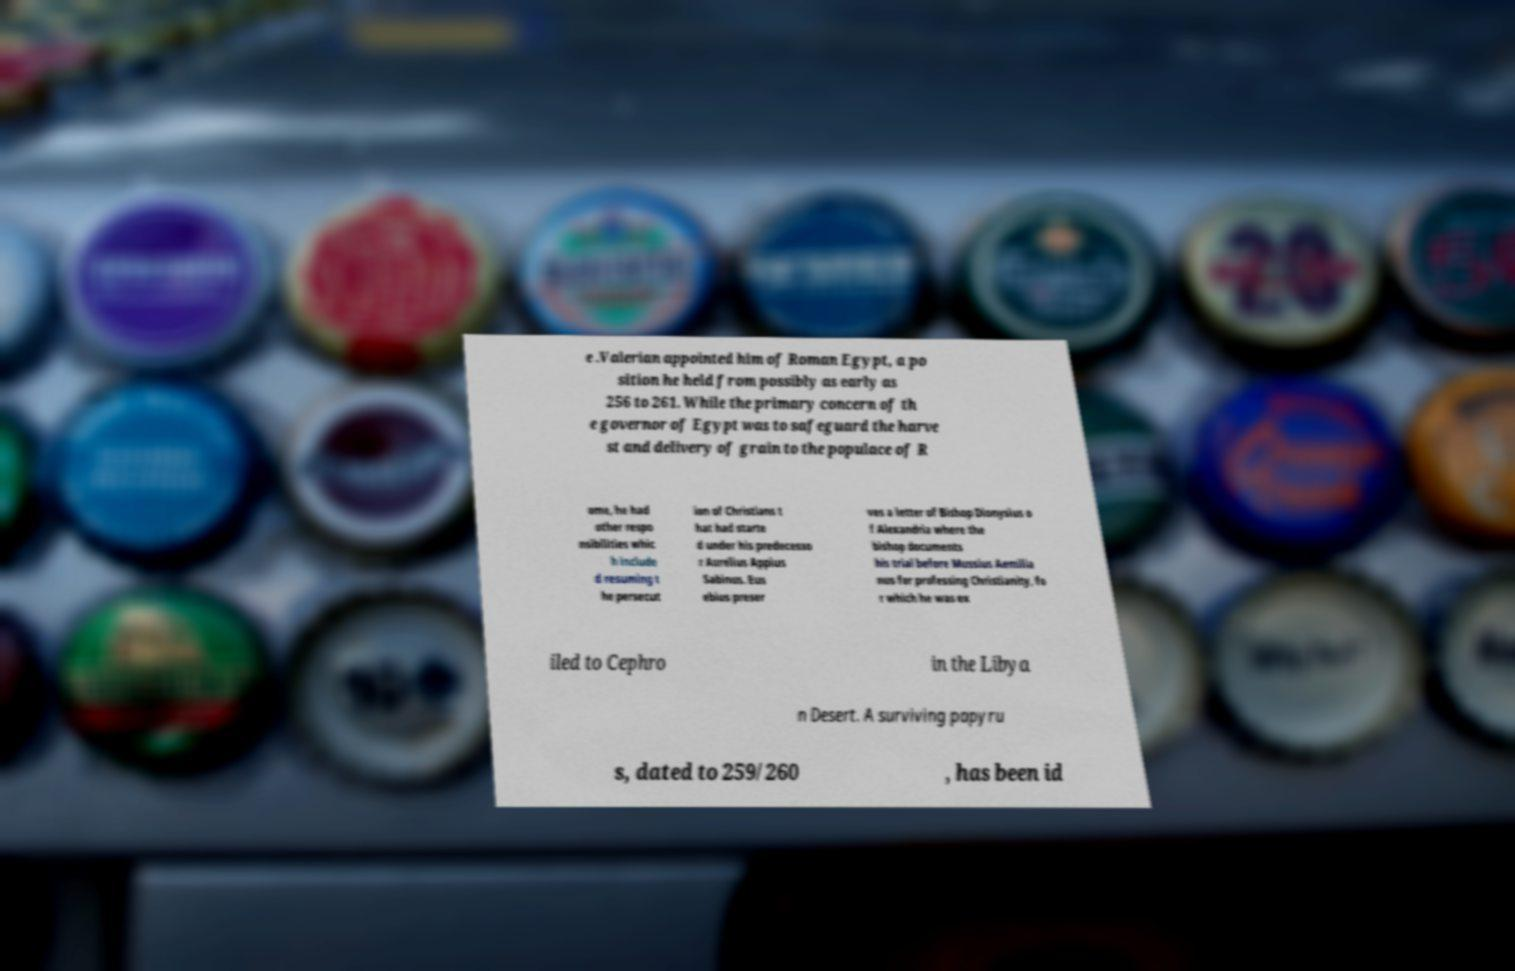For documentation purposes, I need the text within this image transcribed. Could you provide that? e .Valerian appointed him of Roman Egypt, a po sition he held from possibly as early as 256 to 261. While the primary concern of th e governor of Egypt was to safeguard the harve st and delivery of grain to the populace of R ome, he had other respo nsibilities whic h include d resuming t he persecut ion of Christians t hat had starte d under his predecesso r Aurelius Appius Sabinus. Eus ebius preser ves a letter of Bishop Dionysius o f Alexandria where the bishop documents his trial before Mussius Aemilia nus for professing Christianity, fo r which he was ex iled to Cephro in the Libya n Desert. A surviving papyru s, dated to 259/260 , has been id 